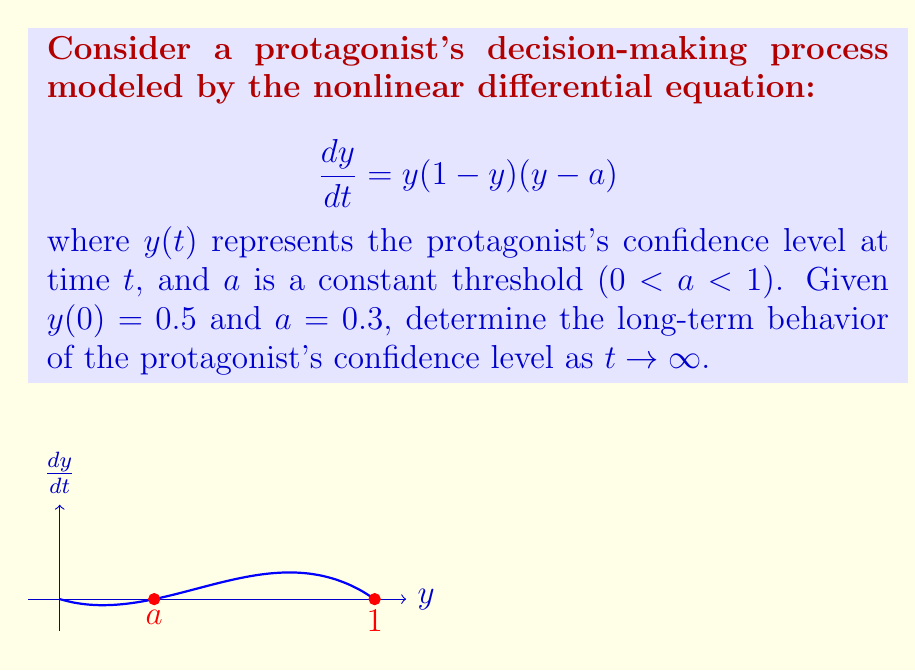Can you answer this question? Let's approach this step-by-step:

1) First, we identify the equilibrium points of the system. These are the values of $y$ where $\frac{dy}{dt} = 0$:
   
   $y(1-y)(y-a) = 0$
   
   This gives us three equilibrium points: $y = 0$, $y = a = 0.3$, and $y = 1$.

2) To determine the stability of these equilibrium points, we need to analyze the behavior of $\frac{dy}{dt}$ near each point:

   - Near $y = 0$: $\frac{dy}{dt} > 0$, so this is an unstable equilibrium.
   - Near $y = 0.3$: $\frac{dy}{dt} < 0$ for $y$ slightly greater than 0.3, and $\frac{dy}{dt} > 0$ for $y$ slightly less than 0.3. This is an unstable equilibrium.
   - Near $y = 1$: $\frac{dy}{dt} < 0$, so this is a stable equilibrium.

3) The initial condition $y(0) = 0.5$ is between $a = 0.3$ and $1$.

4) For $y > a$, we have $\frac{dy}{dt} > 0$, meaning $y$ will increase over time.

5) As $y$ approaches 1, $\frac{dy}{dt}$ approaches 0, but remains positive.

6) Therefore, as $t \to \infty$, $y(t)$ will approach 1 asymptotically.

This means that the protagonist's confidence level will gradually increase and approach 1 (full confidence) in the long term.
Answer: $\lim_{t \to \infty} y(t) = 1$ 